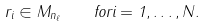Convert formula to latex. <formula><loc_0><loc_0><loc_500><loc_500>r _ { i } \in M _ { n _ { \ell } } \quad f o r i = 1 , \dots , N .</formula> 